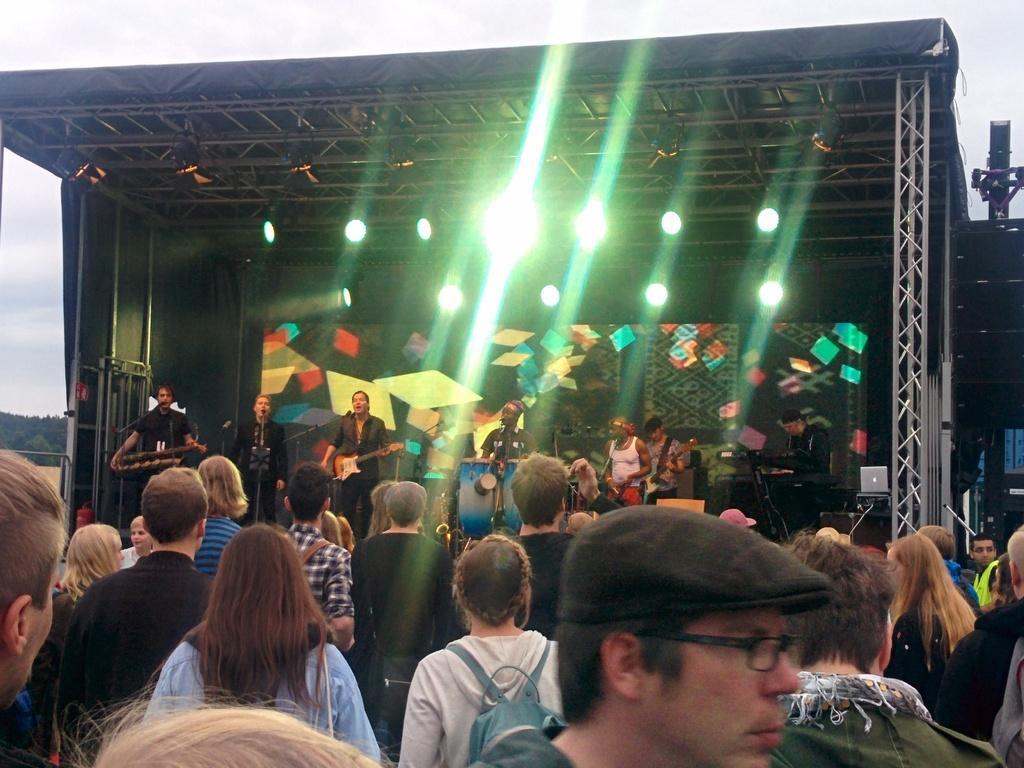Please provide a concise description of this image. There is a group of persons standing and performing on the stage as we can see in the middle of this image and there is a crowd at the bottom of this image. We can see the lights to the stage. 